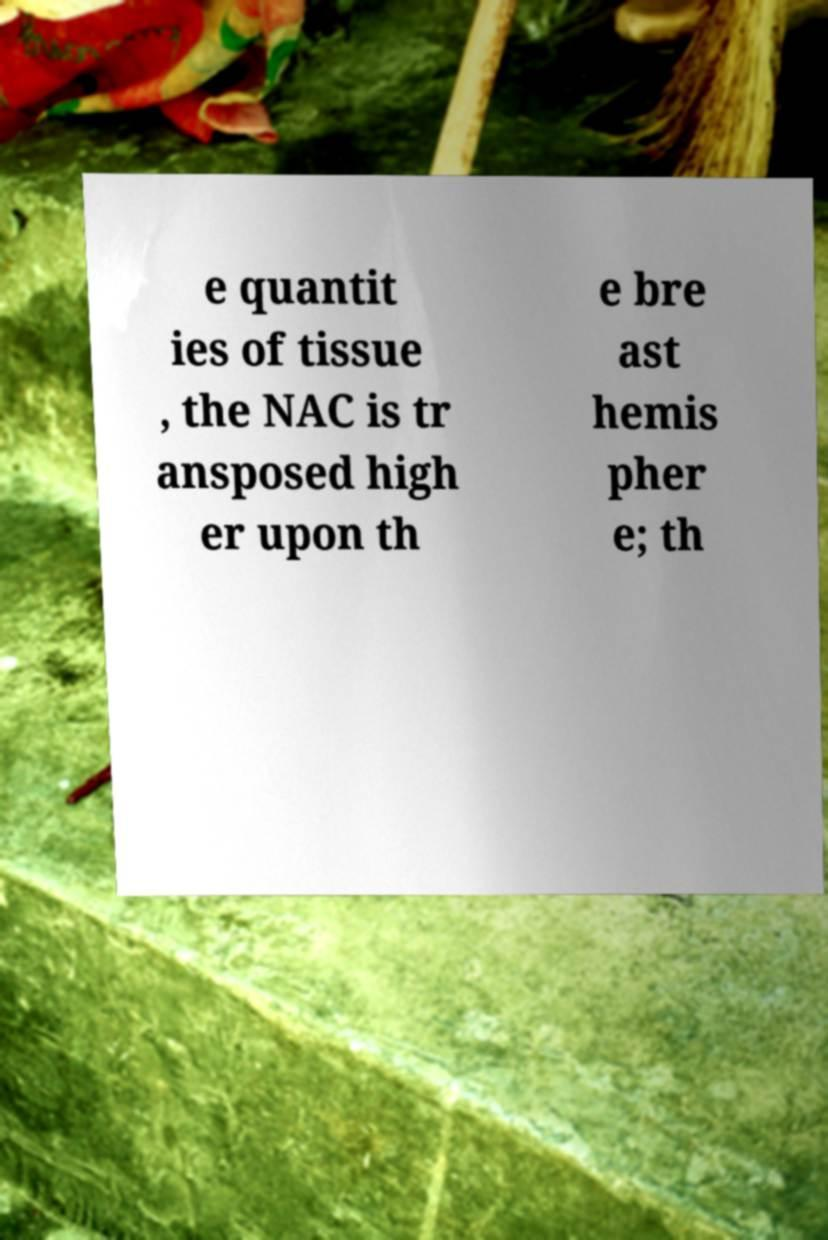Could you assist in decoding the text presented in this image and type it out clearly? e quantit ies of tissue , the NAC is tr ansposed high er upon th e bre ast hemis pher e; th 